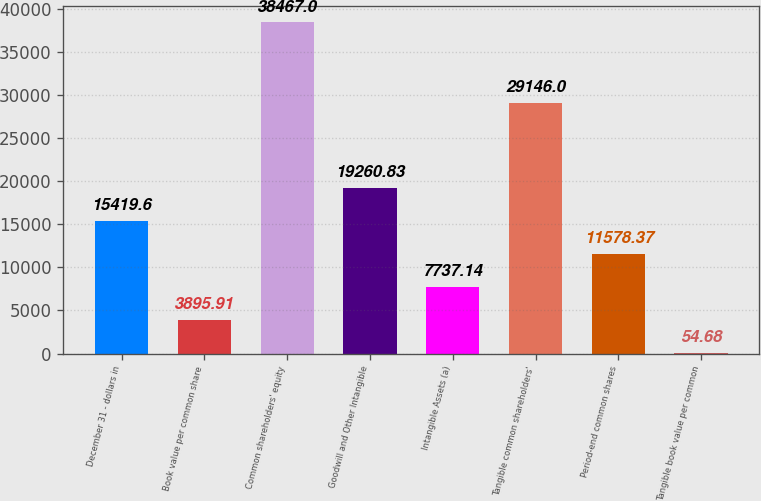Convert chart to OTSL. <chart><loc_0><loc_0><loc_500><loc_500><bar_chart><fcel>December 31 - dollars in<fcel>Book value per common share<fcel>Common shareholders' equity<fcel>Goodwill and Other Intangible<fcel>Intangible Assets (a)<fcel>Tangible common shareholders'<fcel>Period-end common shares<fcel>Tangible book value per common<nl><fcel>15419.6<fcel>3895.91<fcel>38467<fcel>19260.8<fcel>7737.14<fcel>29146<fcel>11578.4<fcel>54.68<nl></chart> 